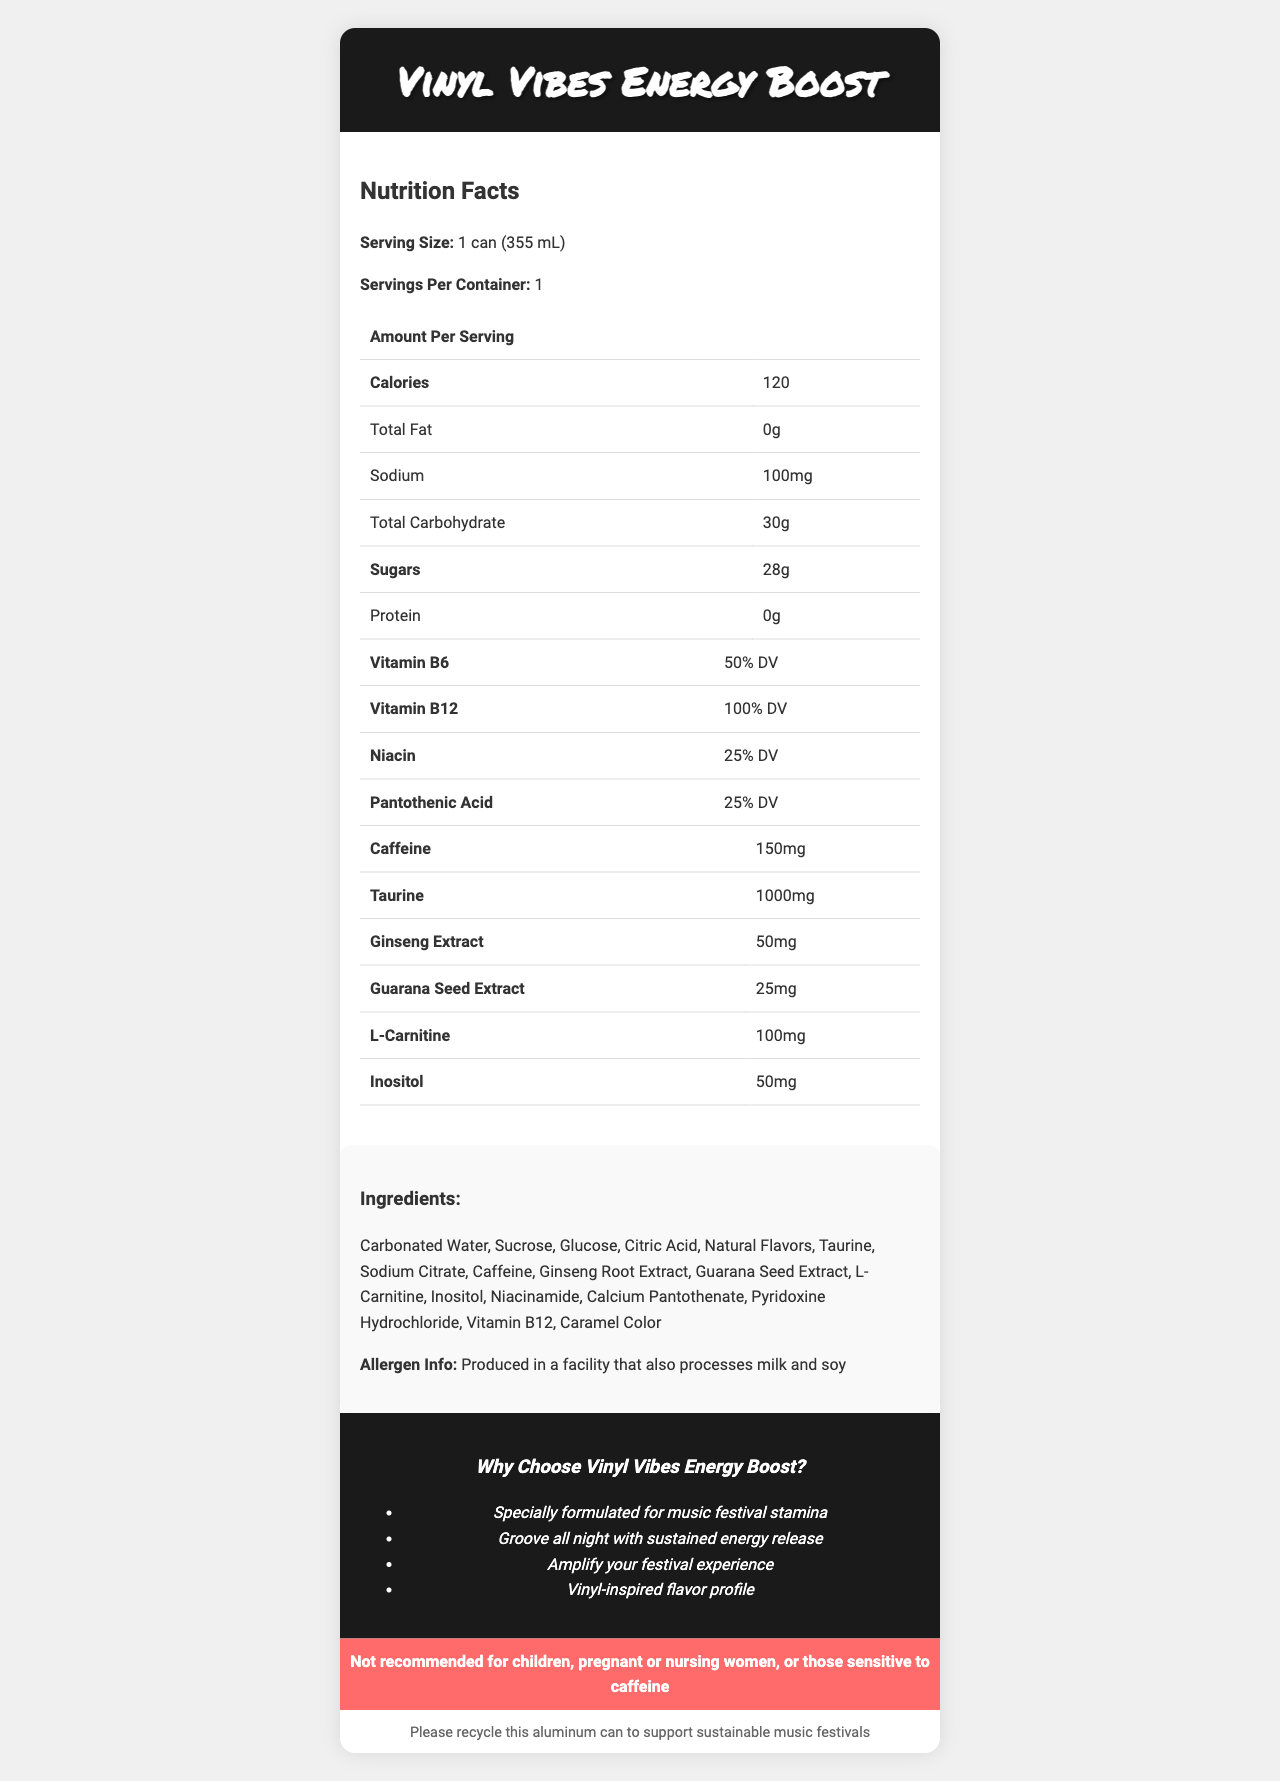what is the serving size of Vinyl Vibes Energy Boost? The serving size is explicitly stated in the nutrition facts section as "1 can (355 mL)".
Answer: 1 can (355 mL) how much caffeine is in one can? The amount of caffeine per can is listed in the nutrition facts section as "150 mg".
Answer: 150 mg how many grams of sugars are in one serving? The document shows the total sugars content in the nutrition facts section as "28 g".
Answer: 28 g what is the total carbohydrate content per serving? The total carbohydrate content per serving is listed as "30 g" in the nutrition facts section.
Answer: 30 g what percentage of the daily value for vitamin B12 does one serving provide? The vitamin B12 content is given as "100% DV" in the nutrition facts section.
Answer: 100% DV what is the main target market for Vinyl Vibes Energy Boost? A. College students B. Office workers C. Music festival attendees The marketing claims section mentions "Specially formulated for music festival stamina" and "Amplify your festival experience", indicating the target market is music festival attendees.
Answer: C which ingredient is not in Vinyl Vibes Energy Boost? A. Taurine B. Caffeine C. Aspartame The ingredient list does not mention Aspartame. Taurine and caffeine are listed as ingredients.
Answer: C is Vinyl Vibes Energy Boost suitable for pregnant women? The disclaimer section clearly states "Not recommended for children, pregnant or nursing women, or those sensitive to caffeine".
Answer: No does the product have any allergen warnings? The allergen info section mentions "Produced in a facility that also processes milk and soy".
Answer: Yes what is the purpose of the recycling information in the document? The recycling section contains the statement "Please recycle this aluminum can to support sustainable music festivals".
Answer: To encourage recycling the aluminum can to support sustainable music festivals summarize the main content of the Nutrition Facts Label for Vinyl Vibes Energy Boost The summary encompasses the overall content: nutrition facts, marketing claims, allergen warnings, and sustainability message.
Answer: The document provides detailed nutrition facts for the Vinyl Vibes Energy Boost, including serving size, calorie content, and amounts of various nutrients and ingredients. It is marketed towards music festival attendees with claims of providing sustained energy and a vinyl-inspired flavor. The document also includes allergen information, a disclaimer, and encourages recycling. how much niacin is in one serving of Vinyl Vibes Energy Boost? The document specifies the niacin content as "25% DV" in the nutrition facts section.
Answer: 25% DV how much taurine does each can contain? The nutrition facts section lists the taurine content as "1000 mg".
Answer: 1000 mg what percentage of the daily value for vitamin B6 can be obtained from one can? The document shows the vitamin B6 content as "50% DV" in the nutrition facts section.
Answer: 50% DV identify the flavor profile of Vinyl Vibes Energy Boost from the document The marketing claims section lists "Vinyl-inspired flavor profile", suggesting the flavor theme.
Answer: Vinyl-inspired flavor profile what type of facility is Vinyl Vibes Energy Boost produced in? The document only mentions that the product is produced in a facility that also processes milk and soy but does not provide specific information about the type of facility.
Answer: Cannot be determined 